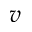<formula> <loc_0><loc_0><loc_500><loc_500>v</formula> 